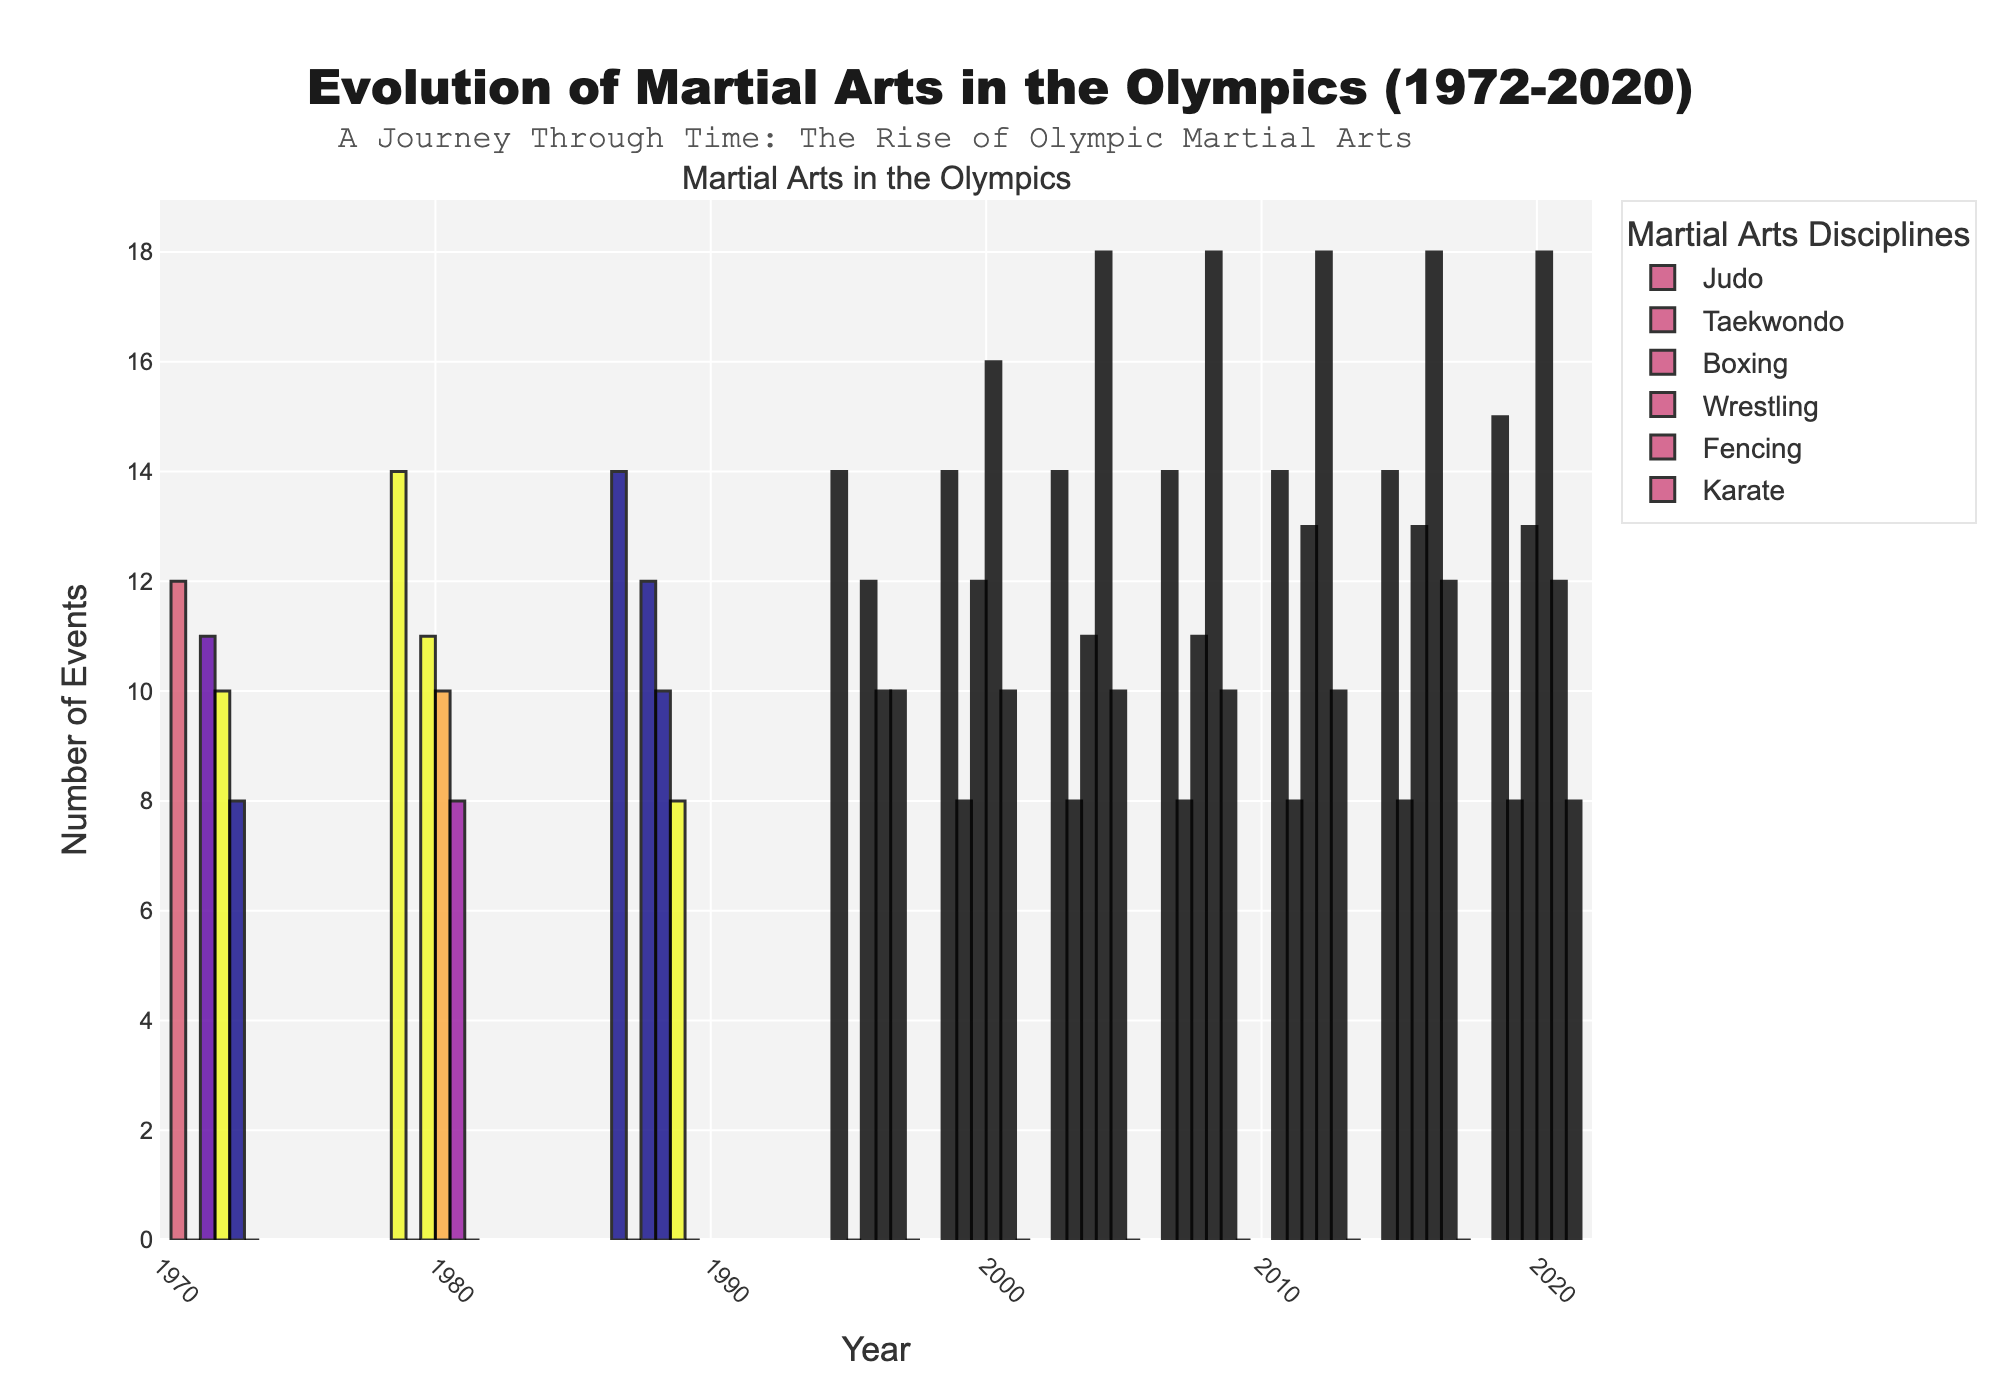Which martial art discipline first appeared in the Olympics in 2000? Looking at the bar chart, we see that Taekwondo first shows a number of events in the year 2000 column. All other disciplines had events before 2000, or their first appearance is marked clearly at a later year.
Answer: Taekwondo How many total events were there for Judo and Taekwondo combined in 2008? From the chart, in 2008, Judo has 14 events and Taekwondo has 8 events. Adding these together gives 14 + 8 = 22
Answer: 22 Which year had the highest number of events for Wrestling? Observing the height of the bars corresponding to Wrestling, the year with the highest bar is 2004, 2008, 2012, and 2016, all showing 18 events.
Answer: 2004, 2008, 2012, 2016 Between 1972 and 2020, which martial art discipline shows the greatest increase in the number of events? Subtract the number of events in 1972 from the number of events in 2020 for each discipline: Judo (15 - 12 = 3), Taekwondo (8 - 0 = 8), Boxing (13 - 11 = 2), Wrestling (18 - 10 = 8), Fencing (12 - 8 = 4), Karate (8 - 0 = 8). Taekwondo, Wrestling, and Karate all show the greatest increase of 8 events.
Answer: Taekwondo, Wrestling, Karate What is the sum of events for Fencing over all years shown? Summing the events for Fencing from the bars or data table: 8 + 8 + 8 + 10 + 10 + 10 + 10 + 10 + 12 + 12 = 98
Answer: 98 Which martial art had no events before 2020 and finally appeared in that year? Noticing that there are no bars for Karate until the year 2020, it means Karate appeared in the Olympics only in 2020.
Answer: Karate Compare the trend in the number of events for Judo and Boxing. What is the difference in the number of events between Judo and Boxing in 2016? From the bar chart, in 2016, Judo has 14 events and Boxing has 13 events. The difference is 14 - 13 = 1
Answer: 1 From 2000 onwards, which martial art discipline consistently had the same number of events each year? Observing the bar heights from 2000 onwards, Taekwondo consistently shows 8 events each year.
Answer: Taekwondo 